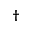<formula> <loc_0><loc_0><loc_500><loc_500>\dagger</formula> 